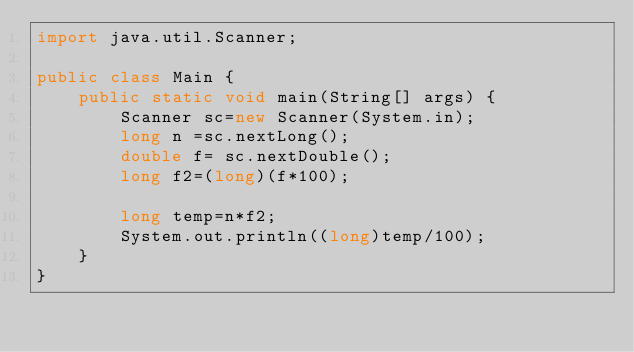<code> <loc_0><loc_0><loc_500><loc_500><_Java_>import java.util.Scanner;

public class Main {
	public static void main(String[] args) {
		Scanner sc=new Scanner(System.in);
		long n =sc.nextLong();
		double f= sc.nextDouble();
		long f2=(long)(f*100);

		long temp=n*f2;
		System.out.println((long)temp/100);
	}
}
</code> 